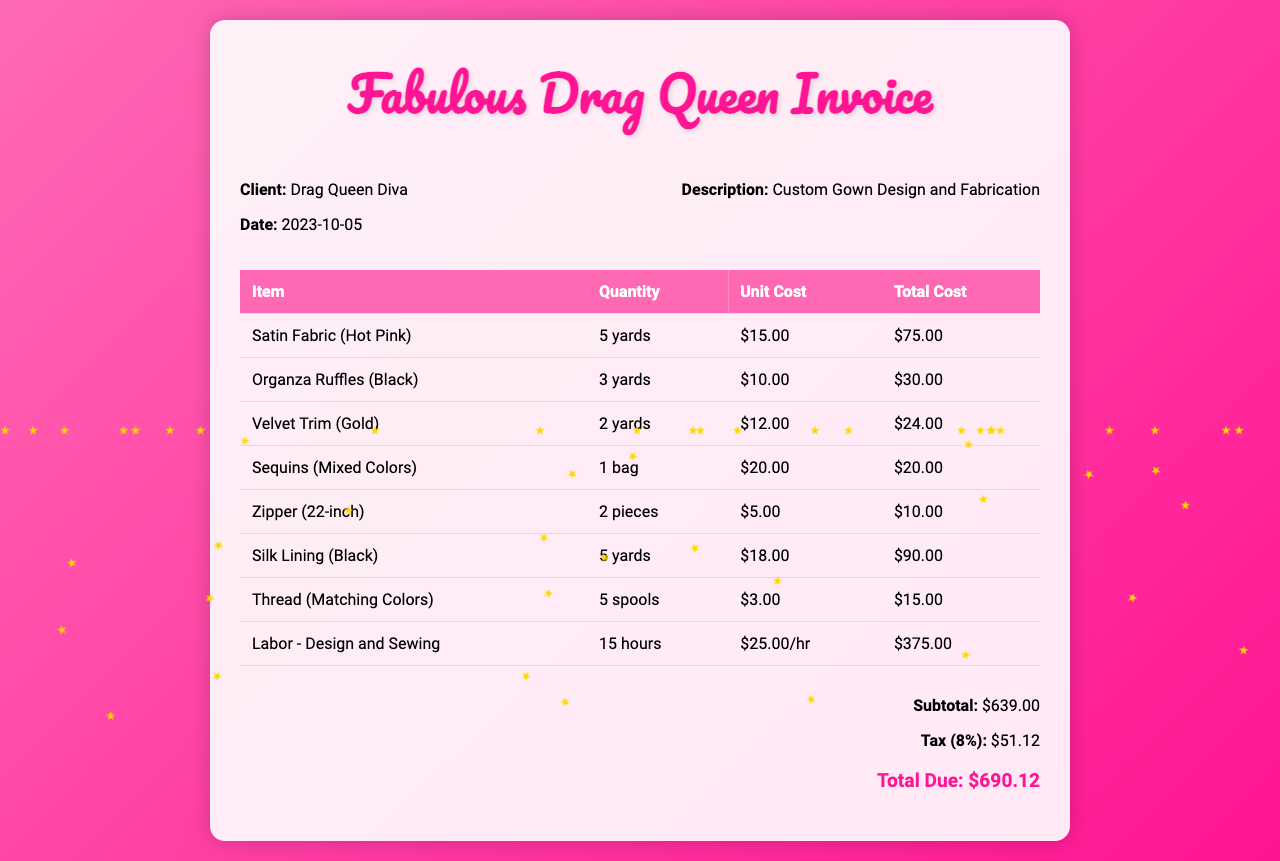What is the client name? The client's name is mentioned in the invoice details section.
Answer: Drag Queen Diva What is the date of the invoice? The date is noted in the invoice details, specifically as the date it was created.
Answer: 2023-10-05 What is the total cost for the satin fabric? The total cost for the satin fabric is found in the itemized costs table.
Answer: $75.00 How many yards of organza ruffles were used? The quantity of organza ruffles is specified in the itemized section of the table.
Answer: 3 yards What was the labor cost per hour? The cost of labor is detailed in the itemized list with the rate specified for each hour worked.
Answer: $25.00/hr What is the subtotal of the invoice before tax? The subtotal is summarized at the end of the invoice, calculated from the total item costs.
Answer: $639.00 What is the total amount due including tax? The total due is the final amount calculated at the end of the invoice, which includes the subtotal and tax.
Answer: $690.12 How many spools of thread were included? The quantity of thread spools is listed in the itemized costs table under the thread section.
Answer: 5 spools What type of gown is described in the invoice? The description is noted in the invoice details section that summarizes the service provided.
Answer: Custom Gown Design and Fabrication 